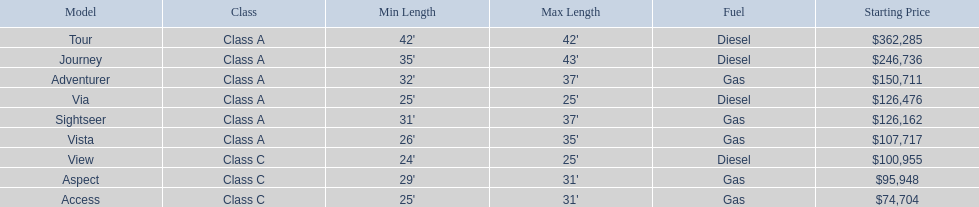Which models of winnebago are there? Tour, Journey, Adventurer, Via, Sightseer, Vista, View, Aspect, Access. Which ones are diesel? Tour, Journey, Sightseer, View. Which of those is the longest? Tour, Journey. Which one has the highest starting price? Tour. 